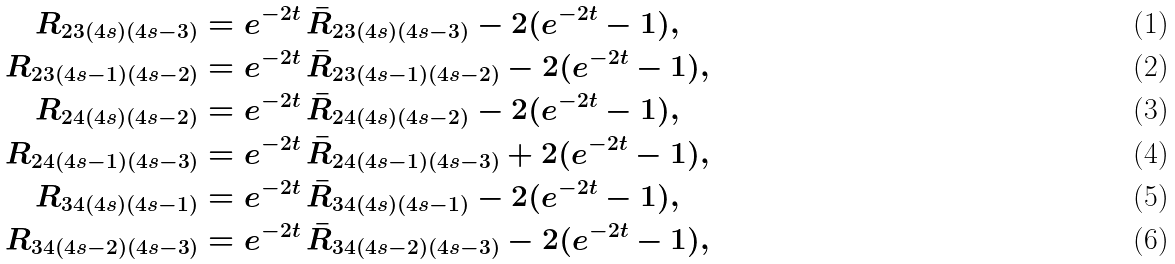Convert formula to latex. <formula><loc_0><loc_0><loc_500><loc_500>R _ { 2 3 ( 4 s ) ( 4 s - 3 ) } & = e ^ { - 2 t } \, \bar { R } _ { 2 3 ( 4 s ) ( 4 s - 3 ) } - 2 ( e ^ { - 2 t } - 1 ) , \\ R _ { 2 3 ( 4 s - 1 ) ( 4 s - 2 ) } & = e ^ { - 2 t } \, \bar { R } _ { 2 3 ( 4 s - 1 ) ( 4 s - 2 ) } - 2 ( e ^ { - 2 t } - 1 ) , \\ R _ { 2 4 ( 4 s ) ( 4 s - 2 ) } & = e ^ { - 2 t } \, \bar { R } _ { 2 4 ( 4 s ) ( 4 s - 2 ) } - 2 ( e ^ { - 2 t } - 1 ) , \\ R _ { 2 4 ( 4 s - 1 ) ( 4 s - 3 ) } & = e ^ { - 2 t } \, \bar { R } _ { 2 4 ( 4 s - 1 ) ( 4 s - 3 ) } + 2 ( e ^ { - 2 t } - 1 ) , \\ R _ { 3 4 ( 4 s ) ( 4 s - 1 ) } & = e ^ { - 2 t } \, \bar { R } _ { 3 4 ( 4 s ) ( 4 s - 1 ) } - 2 ( e ^ { - 2 t } - 1 ) , \\ R _ { 3 4 ( 4 s - 2 ) ( 4 s - 3 ) } & = e ^ { - 2 t } \, \bar { R } _ { 3 4 ( 4 s - 2 ) ( 4 s - 3 ) } - 2 ( e ^ { - 2 t } - 1 ) ,</formula> 